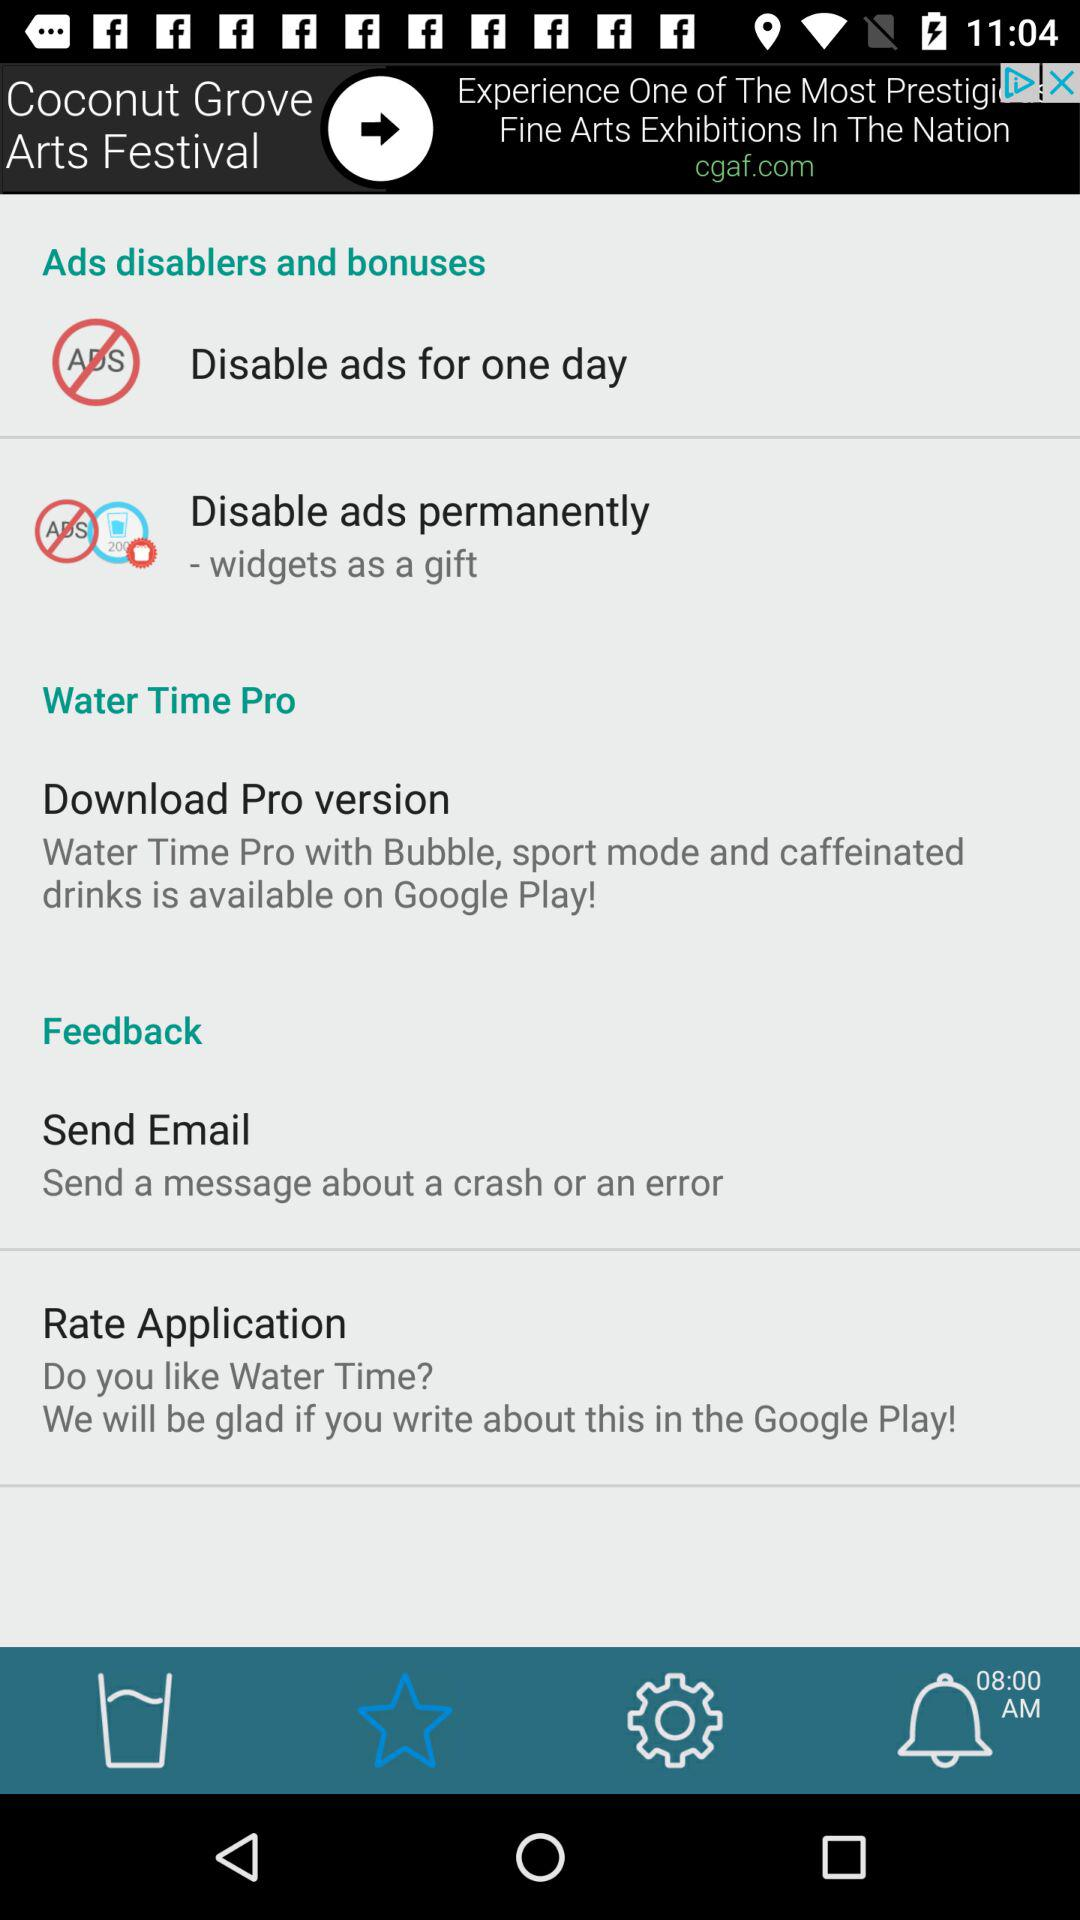What is the time? The time is 08:00 AM. 